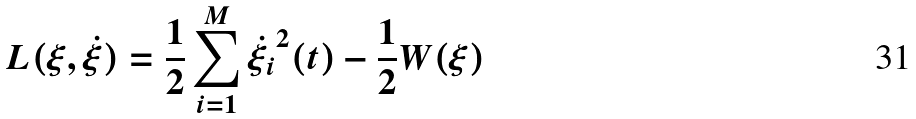Convert formula to latex. <formula><loc_0><loc_0><loc_500><loc_500>L ( \xi , \dot { \xi } ) = \frac { 1 } { 2 } \sum _ { i = 1 } ^ { M } \dot { \xi _ { i } } ^ { 2 } ( t ) - \frac { 1 } { 2 } W ( \xi )</formula> 